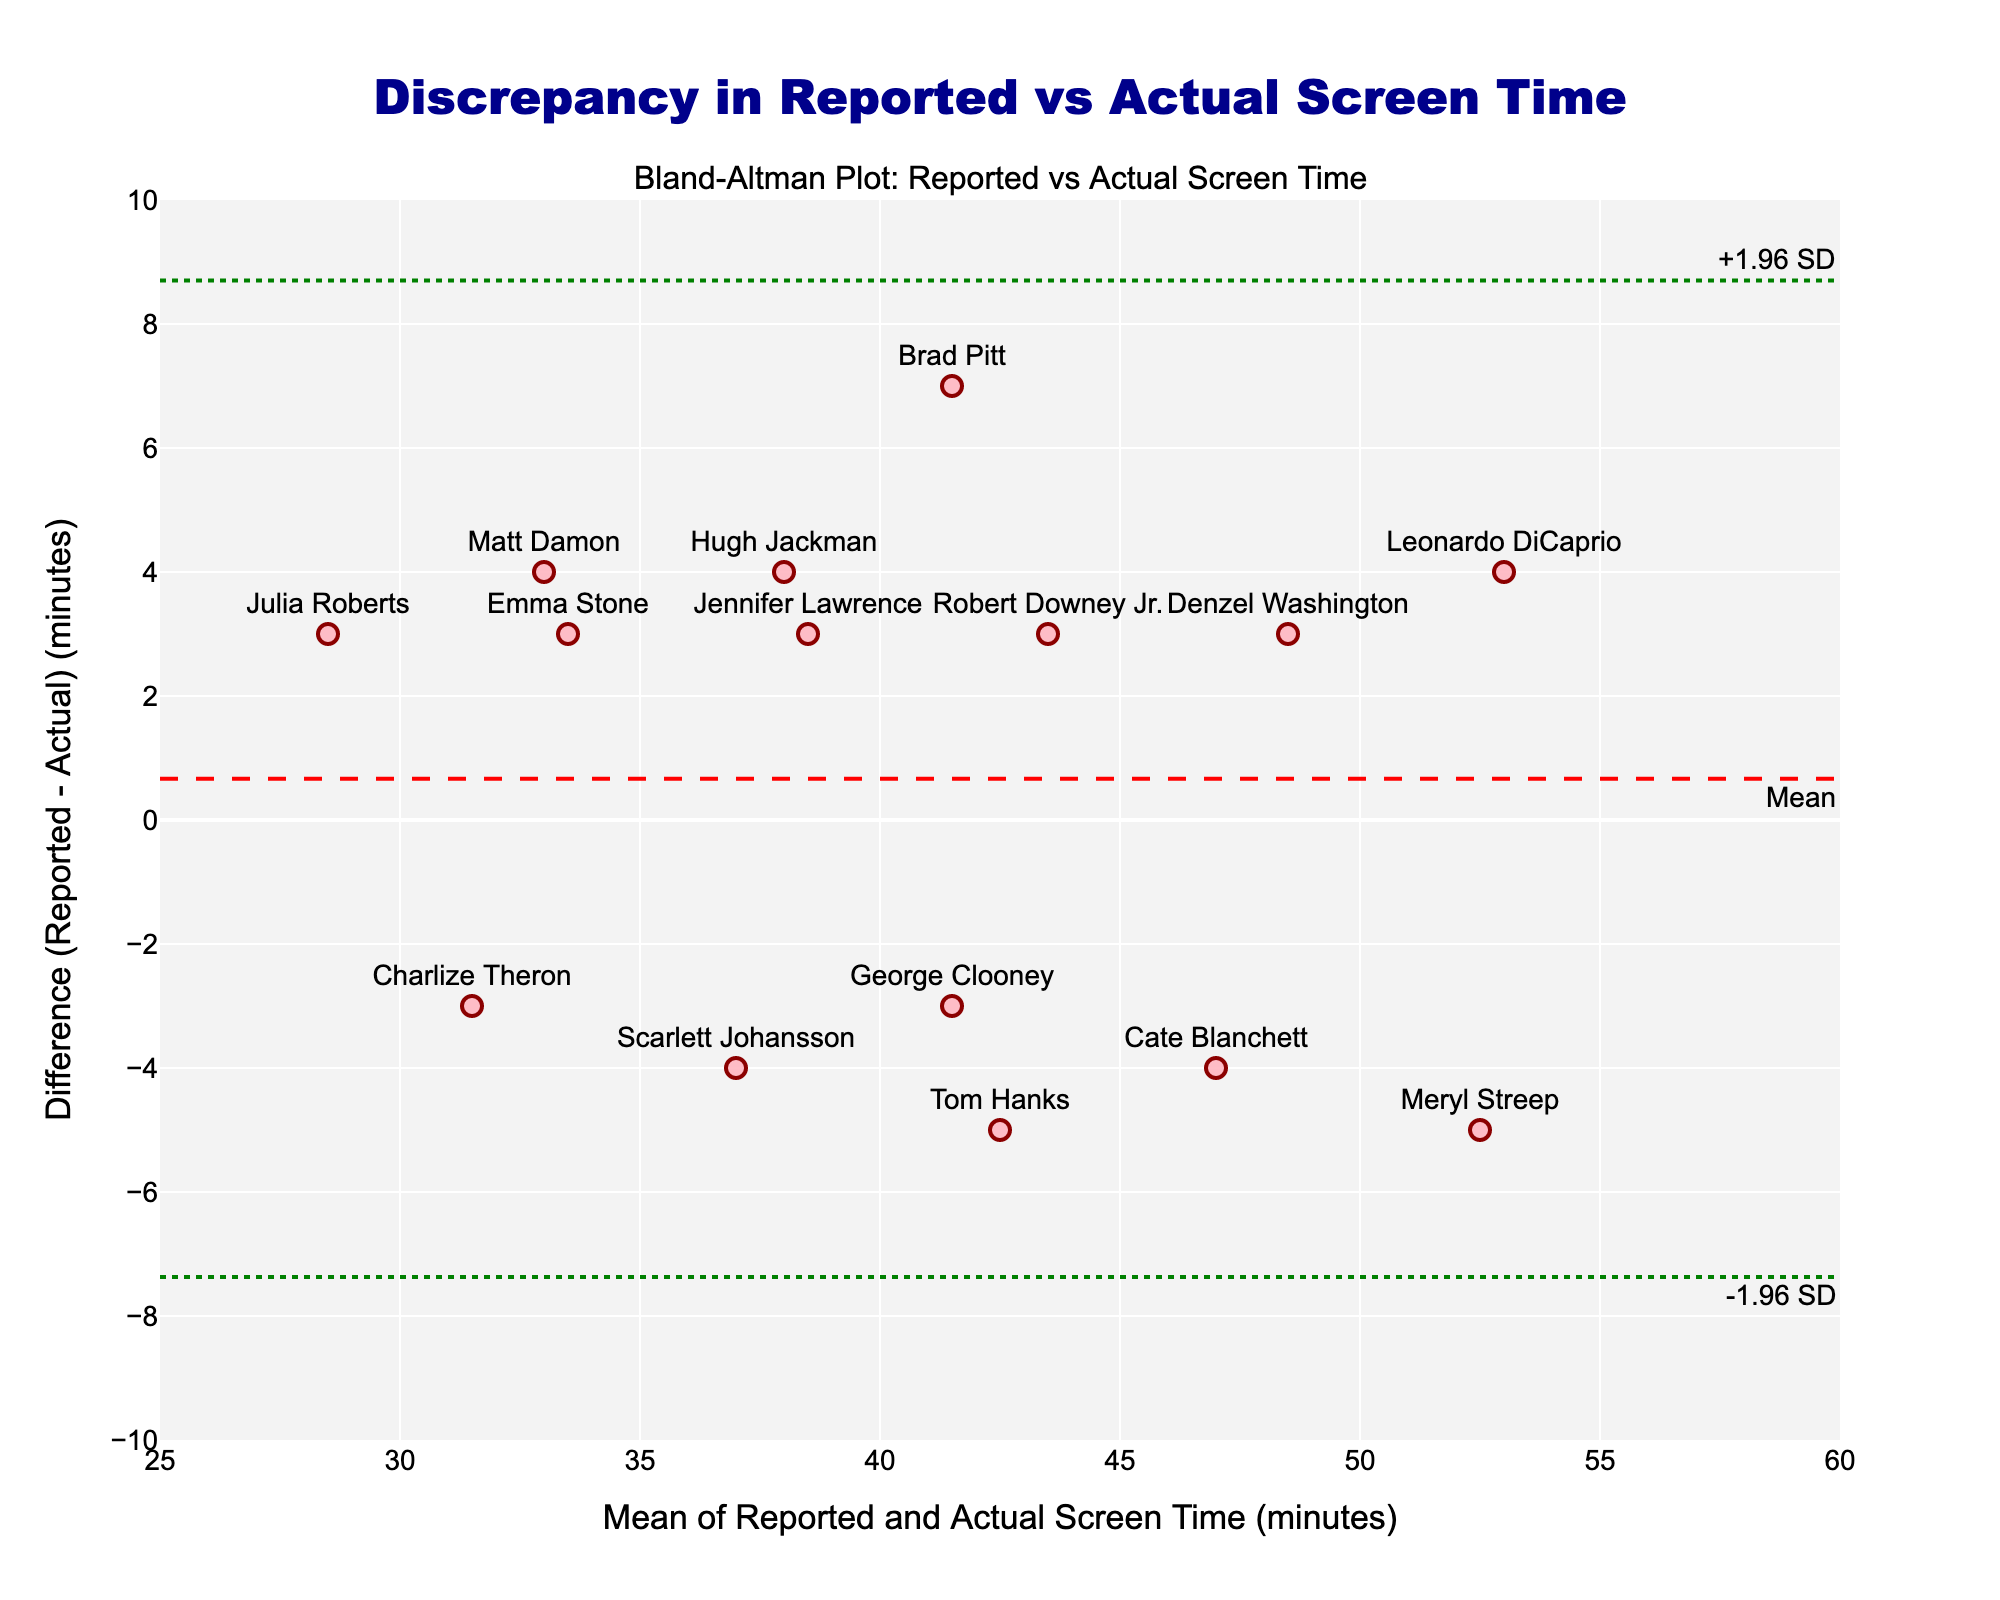How many data points are there in the plot? There are 15 actors listed in the dataset, each represented by a marker in the plot.
Answer: 15 What are the axes labels in the plot? The x-axis is labeled "Mean of Reported and Actual Screen Time (minutes)" and the y-axis is labeled "Difference (Reported - Actual) (minutes)".
Answer: "Mean of Reported and Actual Screen Time (minutes)" and "Difference (Reported - Actual) (minutes)" Which actor has the largest positive discrepancy between reported and actual screen time? The actor with the largest positive discrepancy (difference) is Meryl Streep, with a difference of 5 minutes.
Answer: Meryl Streep Which actor has the largest negative discrepancy between reported and actual screen time? The actor with the largest negative discrepancy (difference) is Brad Pitt, with a difference of -7 minutes.
Answer: Brad Pitt What is the mean of the differences between reported and actual screen time? The mean line on the plot represents the average difference, which is around -0.6 minutes.
Answer: about -0.6 minutes What are the values of the upper and lower limits of agreement (+/- 1.96 SD)? The upper limit (+1.96 SD) is approximately 5.6, and the lower limit (-1.96 SD) is approximately -6.8.
Answer: about 5.6 and -6.8 Which actor is closest to the mean difference line? The actor closest to the mean difference line is George Clooney, with a difference near -3 minutes.
Answer: George Clooney Does any actor fall outside the limits of agreement? All actors' differences fall within the upper and lower limits of agreement, no actor is outside these limits.
Answer: No Is the reported screen time generally overestimated or underestimated compared to the actual screen time? There are more points below the zero line than above, indicating that reported screen time tends to be slightly overestimated.
Answer: Slightly overestimated 